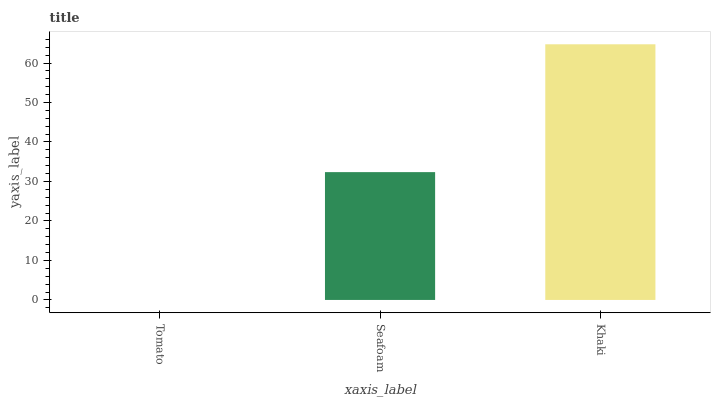Is Tomato the minimum?
Answer yes or no. Yes. Is Khaki the maximum?
Answer yes or no. Yes. Is Seafoam the minimum?
Answer yes or no. No. Is Seafoam the maximum?
Answer yes or no. No. Is Seafoam greater than Tomato?
Answer yes or no. Yes. Is Tomato less than Seafoam?
Answer yes or no. Yes. Is Tomato greater than Seafoam?
Answer yes or no. No. Is Seafoam less than Tomato?
Answer yes or no. No. Is Seafoam the high median?
Answer yes or no. Yes. Is Seafoam the low median?
Answer yes or no. Yes. Is Tomato the high median?
Answer yes or no. No. Is Tomato the low median?
Answer yes or no. No. 